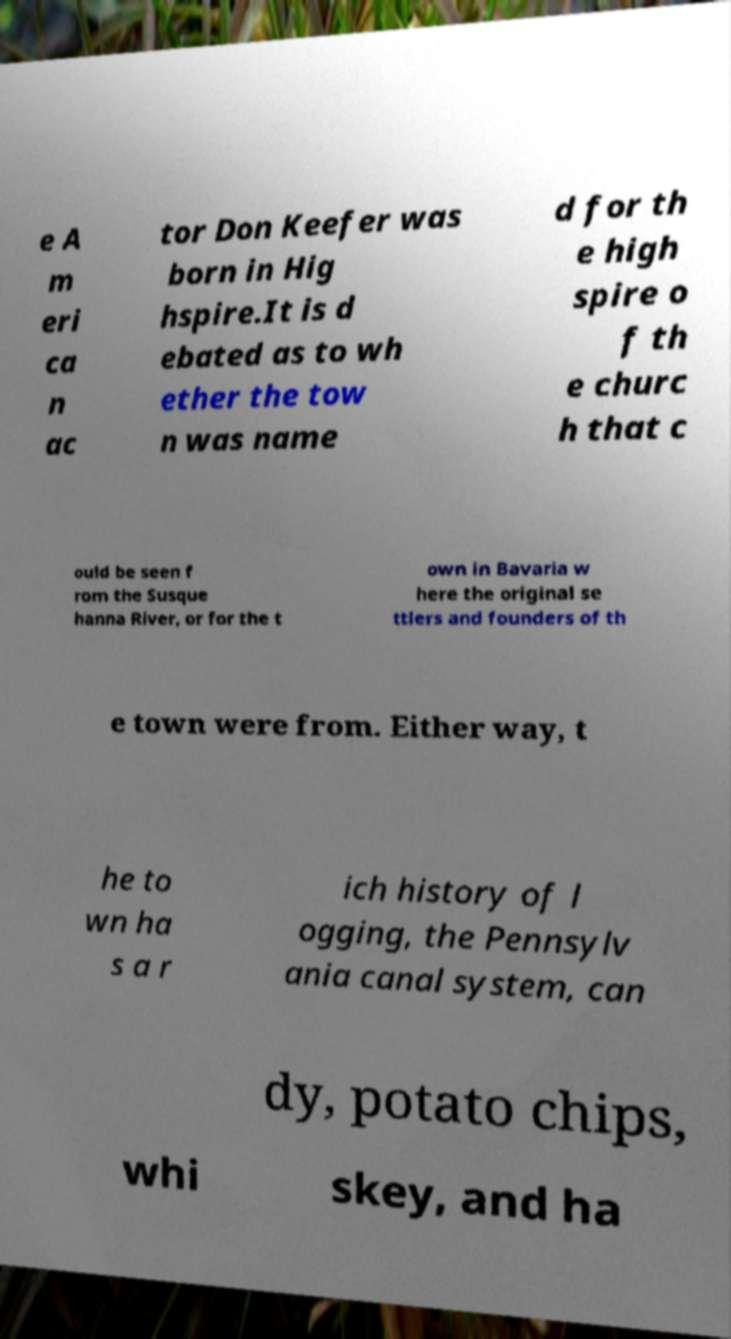I need the written content from this picture converted into text. Can you do that? e A m eri ca n ac tor Don Keefer was born in Hig hspire.It is d ebated as to wh ether the tow n was name d for th e high spire o f th e churc h that c ould be seen f rom the Susque hanna River, or for the t own in Bavaria w here the original se ttlers and founders of th e town were from. Either way, t he to wn ha s a r ich history of l ogging, the Pennsylv ania canal system, can dy, potato chips, whi skey, and ha 